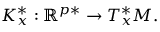<formula> <loc_0><loc_0><loc_500><loc_500>K _ { x } ^ { * } \colon \mathbb { R } ^ { p * } \to T _ { x } ^ { * } M .</formula> 